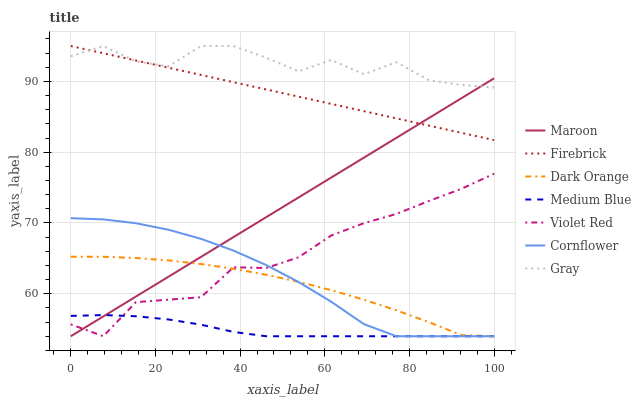Does Medium Blue have the minimum area under the curve?
Answer yes or no. Yes. Does Gray have the maximum area under the curve?
Answer yes or no. Yes. Does Violet Red have the minimum area under the curve?
Answer yes or no. No. Does Violet Red have the maximum area under the curve?
Answer yes or no. No. Is Maroon the smoothest?
Answer yes or no. Yes. Is Gray the roughest?
Answer yes or no. Yes. Is Violet Red the smoothest?
Answer yes or no. No. Is Violet Red the roughest?
Answer yes or no. No. Does Dark Orange have the lowest value?
Answer yes or no. Yes. Does Violet Red have the lowest value?
Answer yes or no. No. Does Gray have the highest value?
Answer yes or no. Yes. Does Violet Red have the highest value?
Answer yes or no. No. Is Cornflower less than Gray?
Answer yes or no. Yes. Is Gray greater than Violet Red?
Answer yes or no. Yes. Does Maroon intersect Dark Orange?
Answer yes or no. Yes. Is Maroon less than Dark Orange?
Answer yes or no. No. Is Maroon greater than Dark Orange?
Answer yes or no. No. Does Cornflower intersect Gray?
Answer yes or no. No. 